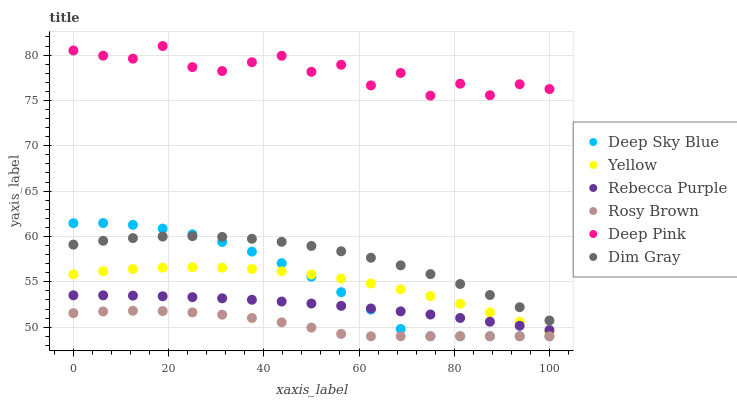Does Rosy Brown have the minimum area under the curve?
Answer yes or no. Yes. Does Deep Pink have the maximum area under the curve?
Answer yes or no. Yes. Does Yellow have the minimum area under the curve?
Answer yes or no. No. Does Yellow have the maximum area under the curve?
Answer yes or no. No. Is Rebecca Purple the smoothest?
Answer yes or no. Yes. Is Deep Pink the roughest?
Answer yes or no. Yes. Is Rosy Brown the smoothest?
Answer yes or no. No. Is Rosy Brown the roughest?
Answer yes or no. No. Does Rosy Brown have the lowest value?
Answer yes or no. Yes. Does Yellow have the lowest value?
Answer yes or no. No. Does Deep Pink have the highest value?
Answer yes or no. Yes. Does Yellow have the highest value?
Answer yes or no. No. Is Rebecca Purple less than Deep Pink?
Answer yes or no. Yes. Is Deep Pink greater than Rosy Brown?
Answer yes or no. Yes. Does Deep Sky Blue intersect Rebecca Purple?
Answer yes or no. Yes. Is Deep Sky Blue less than Rebecca Purple?
Answer yes or no. No. Is Deep Sky Blue greater than Rebecca Purple?
Answer yes or no. No. Does Rebecca Purple intersect Deep Pink?
Answer yes or no. No. 